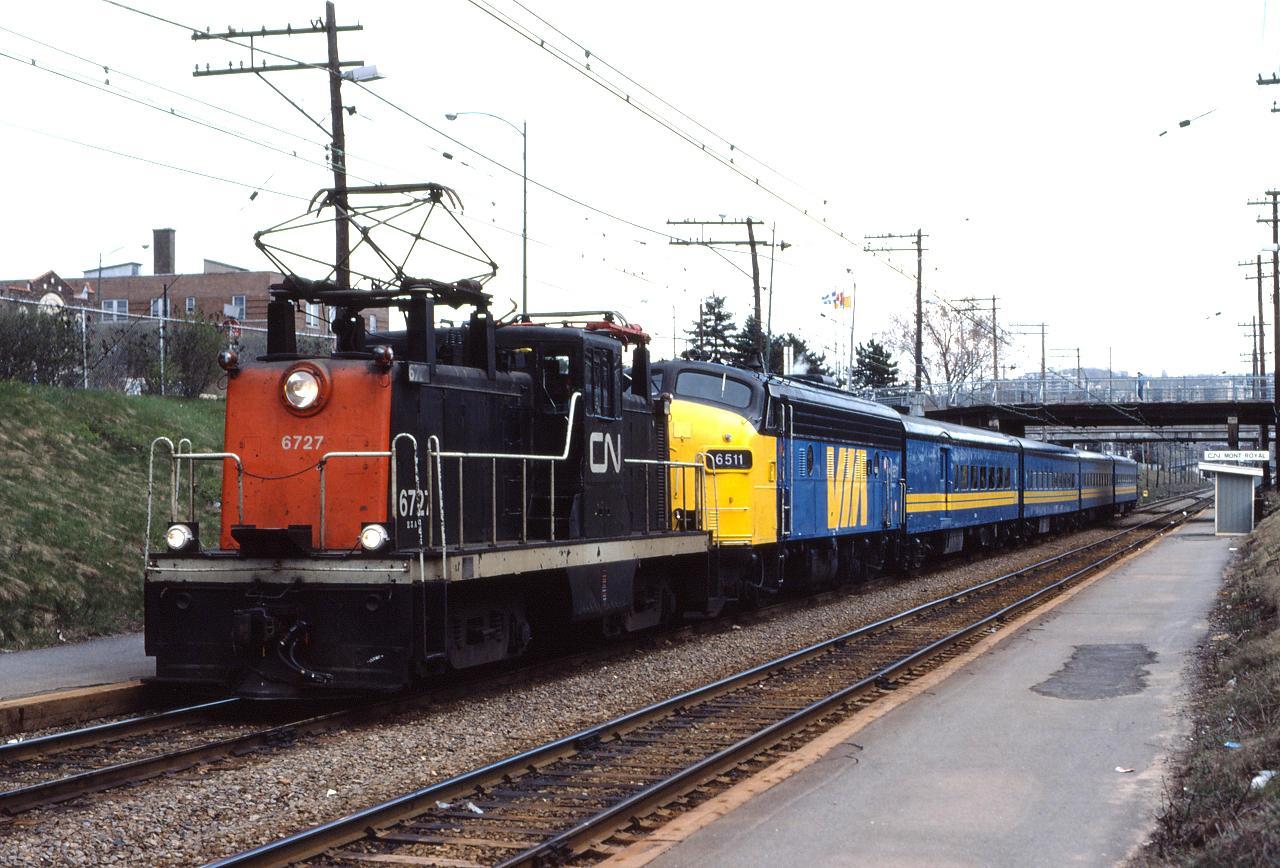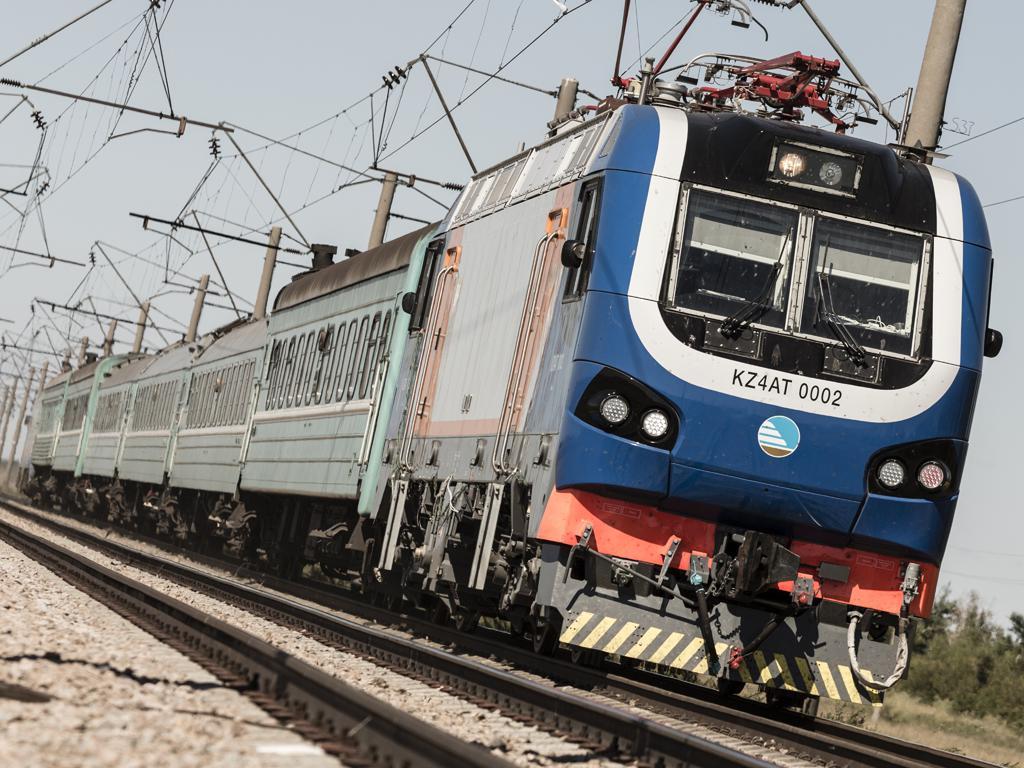The first image is the image on the left, the second image is the image on the right. Evaluate the accuracy of this statement regarding the images: "A train is on a track next to bare-branched trees and a house with a peaked roof in one image.". Is it true? Answer yes or no. No. The first image is the image on the left, the second image is the image on the right. Evaluate the accuracy of this statement regarding the images: "The train in the image on the right has a single windshield.". Is it true? Answer yes or no. No. 